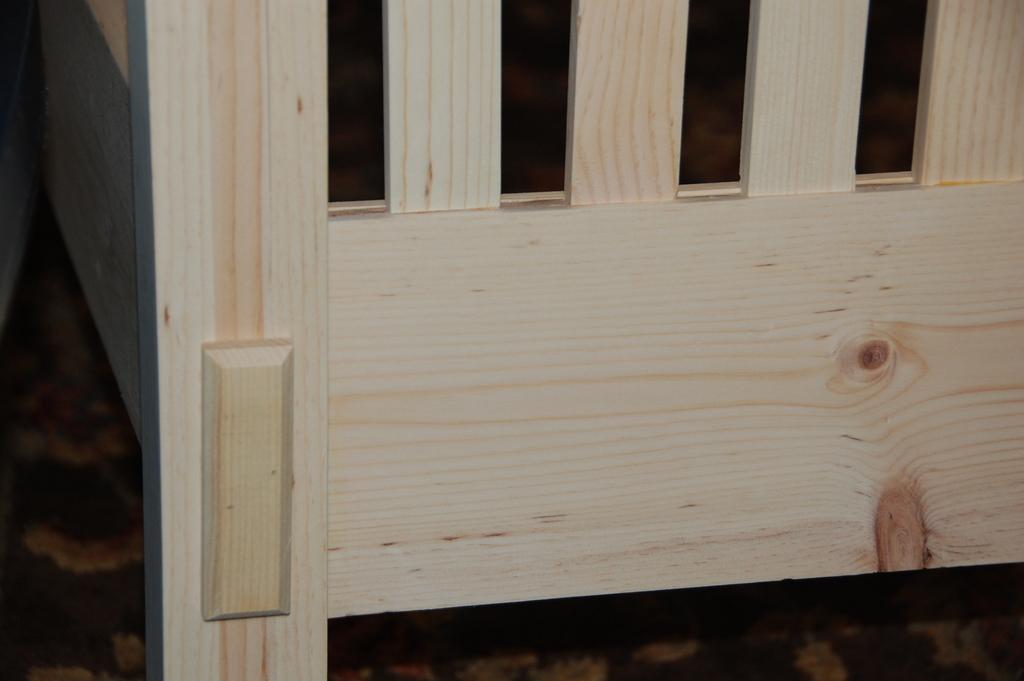What type of furniture is present in the image? There is a wooden cot in the image. What type of dinosaurs can be seen sitting on the throne in the image? There are no dinosaurs or thrones present in the image; it features a wooden cot. How many potatoes are visible on the potato farm in the image? There is no potato farm present in the image; it features a wooden cot. 